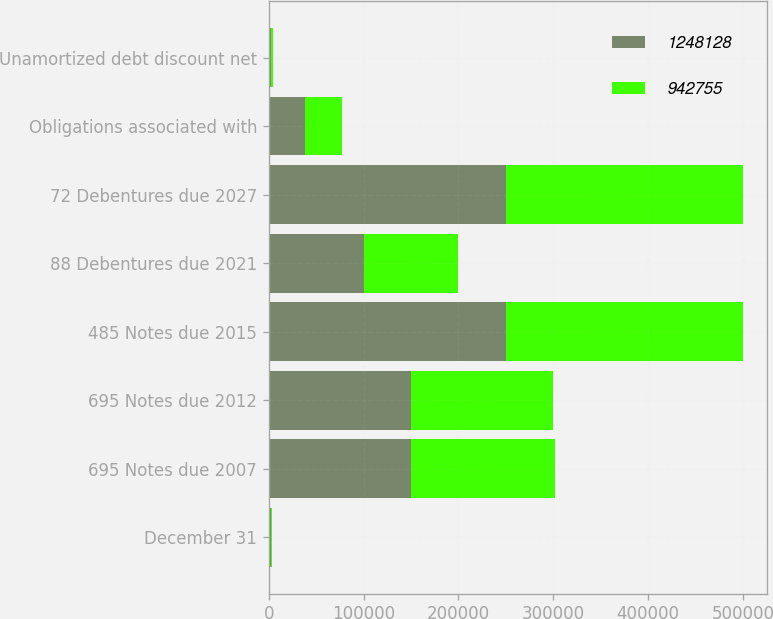<chart> <loc_0><loc_0><loc_500><loc_500><stacked_bar_chart><ecel><fcel>December 31<fcel>695 Notes due 2007<fcel>695 Notes due 2012<fcel>485 Notes due 2015<fcel>88 Debentures due 2021<fcel>72 Debentures due 2027<fcel>Obligations associated with<fcel>Unamortized debt discount net<nl><fcel>1.24813e+06<fcel>2006<fcel>150168<fcel>150000<fcel>250000<fcel>100000<fcel>250000<fcel>38680<fcel>1955<nl><fcel>942755<fcel>2005<fcel>151176<fcel>150000<fcel>250000<fcel>100000<fcel>250000<fcel>38680<fcel>2955<nl></chart> 